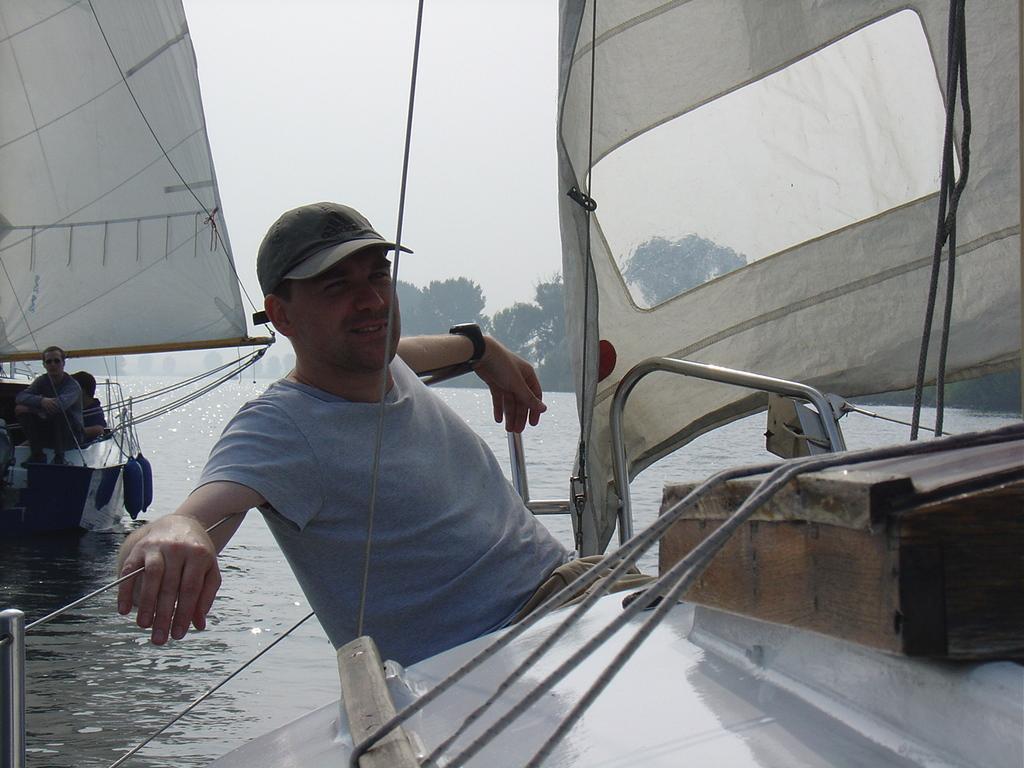In one or two sentences, can you explain what this image depicts? In this image I can see water and on it I can see few boats. I can also see few people are sitting on these boats. In the background I can see number of trees. 